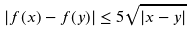<formula> <loc_0><loc_0><loc_500><loc_500>| f ( x ) - f ( y ) | \leq 5 \sqrt { | x - y | }</formula> 